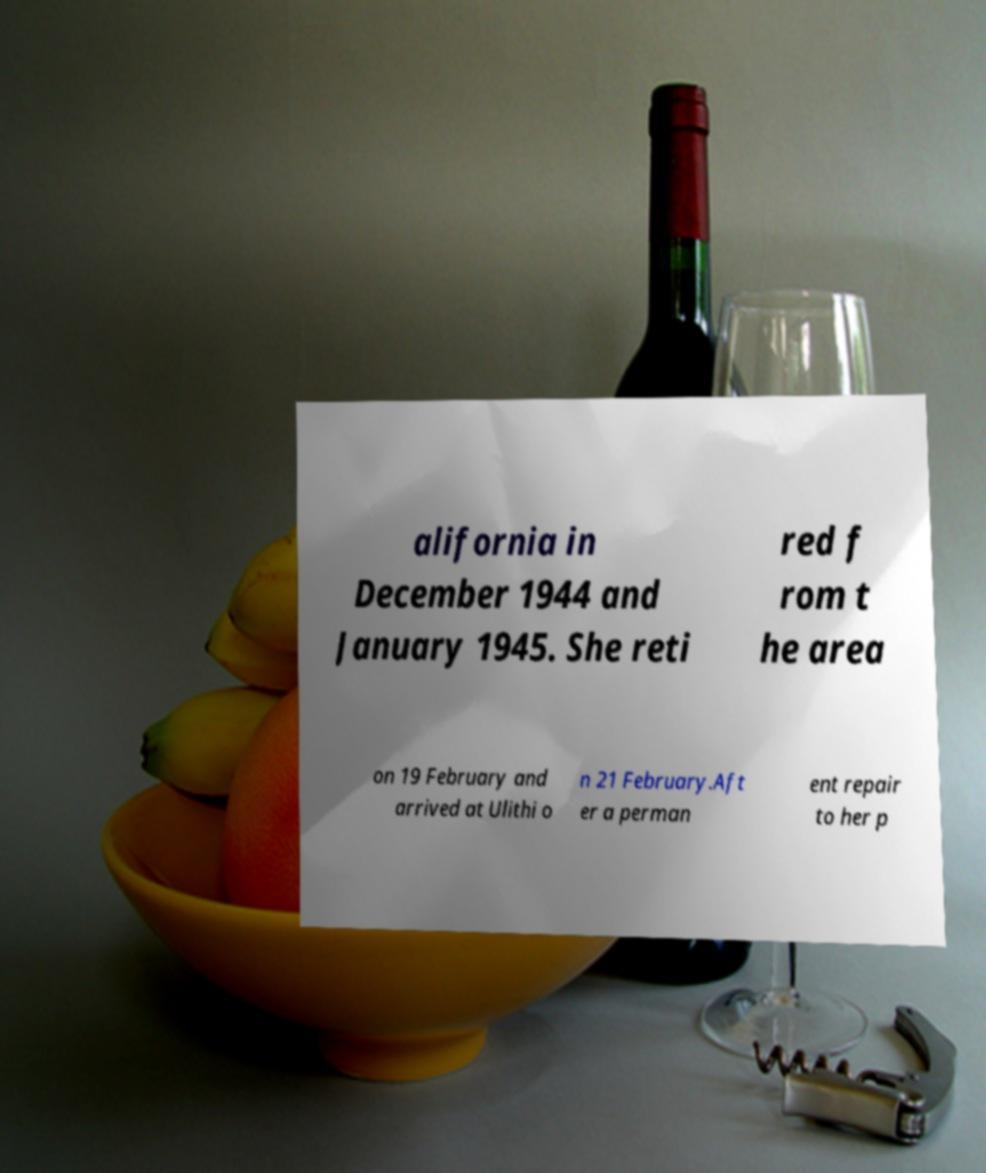There's text embedded in this image that I need extracted. Can you transcribe it verbatim? alifornia in December 1944 and January 1945. She reti red f rom t he area on 19 February and arrived at Ulithi o n 21 February.Aft er a perman ent repair to her p 